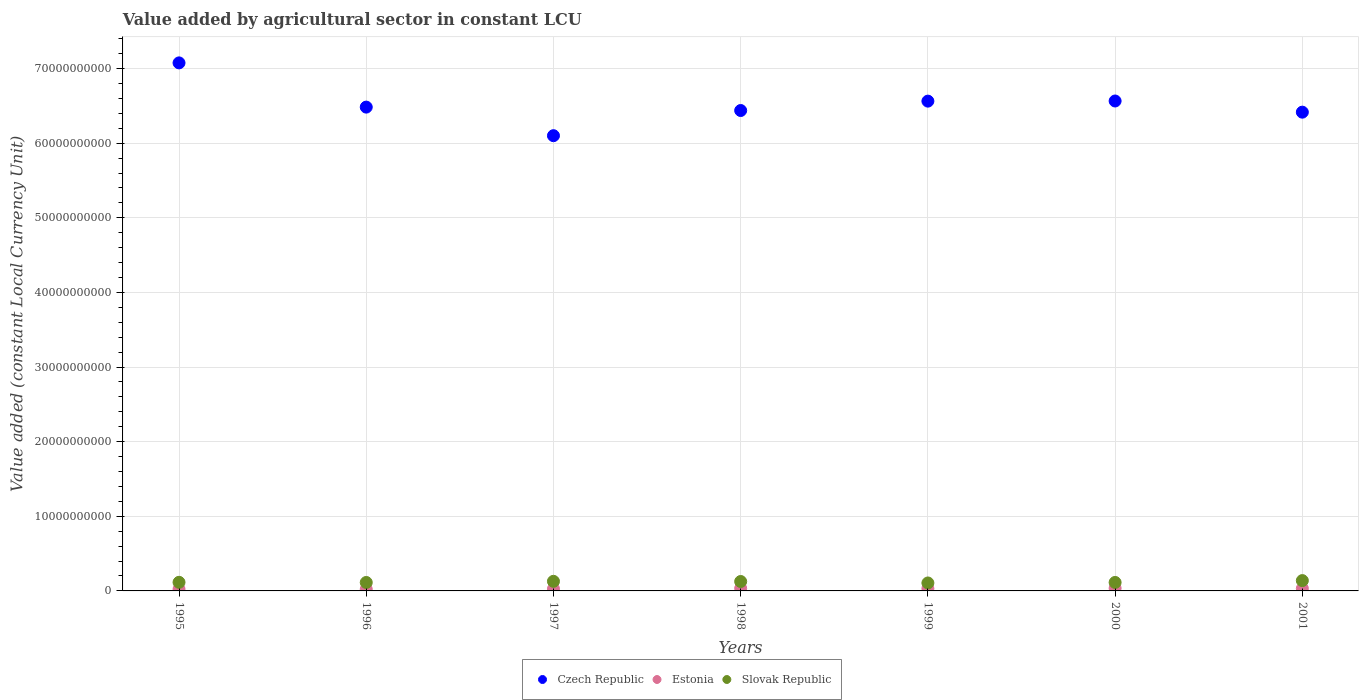What is the value added by agricultural sector in Estonia in 1998?
Offer a terse response. 3.44e+08. Across all years, what is the maximum value added by agricultural sector in Estonia?
Provide a short and direct response. 3.61e+08. Across all years, what is the minimum value added by agricultural sector in Estonia?
Offer a very short reply. 2.31e+08. In which year was the value added by agricultural sector in Estonia minimum?
Provide a short and direct response. 1995. What is the total value added by agricultural sector in Czech Republic in the graph?
Your answer should be very brief. 4.56e+11. What is the difference between the value added by agricultural sector in Czech Republic in 1998 and that in 1999?
Your answer should be compact. -1.26e+09. What is the difference between the value added by agricultural sector in Estonia in 1995 and the value added by agricultural sector in Czech Republic in 2000?
Offer a terse response. -6.54e+1. What is the average value added by agricultural sector in Estonia per year?
Offer a terse response. 2.97e+08. In the year 2000, what is the difference between the value added by agricultural sector in Czech Republic and value added by agricultural sector in Estonia?
Offer a terse response. 6.53e+1. What is the ratio of the value added by agricultural sector in Czech Republic in 2000 to that in 2001?
Offer a terse response. 1.02. Is the difference between the value added by agricultural sector in Czech Republic in 1996 and 1998 greater than the difference between the value added by agricultural sector in Estonia in 1996 and 1998?
Offer a very short reply. Yes. What is the difference between the highest and the second highest value added by agricultural sector in Slovak Republic?
Ensure brevity in your answer.  9.64e+07. What is the difference between the highest and the lowest value added by agricultural sector in Czech Republic?
Keep it short and to the point. 9.76e+09. Is the sum of the value added by agricultural sector in Czech Republic in 1996 and 1997 greater than the maximum value added by agricultural sector in Estonia across all years?
Your answer should be very brief. Yes. Is it the case that in every year, the sum of the value added by agricultural sector in Estonia and value added by agricultural sector in Czech Republic  is greater than the value added by agricultural sector in Slovak Republic?
Your response must be concise. Yes. Is the value added by agricultural sector in Slovak Republic strictly greater than the value added by agricultural sector in Estonia over the years?
Make the answer very short. Yes. Is the value added by agricultural sector in Estonia strictly less than the value added by agricultural sector in Slovak Republic over the years?
Offer a very short reply. Yes. How many years are there in the graph?
Ensure brevity in your answer.  7. What is the difference between two consecutive major ticks on the Y-axis?
Offer a very short reply. 1.00e+1. Does the graph contain grids?
Provide a succinct answer. Yes. Where does the legend appear in the graph?
Your response must be concise. Bottom center. How many legend labels are there?
Your answer should be very brief. 3. How are the legend labels stacked?
Offer a very short reply. Horizontal. What is the title of the graph?
Offer a terse response. Value added by agricultural sector in constant LCU. Does "Bermuda" appear as one of the legend labels in the graph?
Your answer should be compact. No. What is the label or title of the X-axis?
Make the answer very short. Years. What is the label or title of the Y-axis?
Ensure brevity in your answer.  Value added (constant Local Currency Unit). What is the Value added (constant Local Currency Unit) of Czech Republic in 1995?
Provide a short and direct response. 7.08e+1. What is the Value added (constant Local Currency Unit) of Estonia in 1995?
Make the answer very short. 2.31e+08. What is the Value added (constant Local Currency Unit) in Slovak Republic in 1995?
Make the answer very short. 1.15e+09. What is the Value added (constant Local Currency Unit) of Czech Republic in 1996?
Give a very brief answer. 6.48e+1. What is the Value added (constant Local Currency Unit) in Estonia in 1996?
Provide a succinct answer. 2.34e+08. What is the Value added (constant Local Currency Unit) in Slovak Republic in 1996?
Give a very brief answer. 1.13e+09. What is the Value added (constant Local Currency Unit) of Czech Republic in 1997?
Your answer should be very brief. 6.10e+1. What is the Value added (constant Local Currency Unit) of Estonia in 1997?
Make the answer very short. 2.73e+08. What is the Value added (constant Local Currency Unit) of Slovak Republic in 1997?
Ensure brevity in your answer.  1.29e+09. What is the Value added (constant Local Currency Unit) of Czech Republic in 1998?
Provide a succinct answer. 6.44e+1. What is the Value added (constant Local Currency Unit) of Estonia in 1998?
Give a very brief answer. 3.44e+08. What is the Value added (constant Local Currency Unit) in Slovak Republic in 1998?
Your response must be concise. 1.26e+09. What is the Value added (constant Local Currency Unit) of Czech Republic in 1999?
Keep it short and to the point. 6.56e+1. What is the Value added (constant Local Currency Unit) in Estonia in 1999?
Offer a very short reply. 3.06e+08. What is the Value added (constant Local Currency Unit) of Slovak Republic in 1999?
Your answer should be very brief. 1.07e+09. What is the Value added (constant Local Currency Unit) of Czech Republic in 2000?
Offer a very short reply. 6.56e+1. What is the Value added (constant Local Currency Unit) of Estonia in 2000?
Your response must be concise. 3.61e+08. What is the Value added (constant Local Currency Unit) in Slovak Republic in 2000?
Provide a short and direct response. 1.14e+09. What is the Value added (constant Local Currency Unit) in Czech Republic in 2001?
Ensure brevity in your answer.  6.42e+1. What is the Value added (constant Local Currency Unit) of Estonia in 2001?
Your answer should be compact. 3.27e+08. What is the Value added (constant Local Currency Unit) of Slovak Republic in 2001?
Provide a short and direct response. 1.38e+09. Across all years, what is the maximum Value added (constant Local Currency Unit) in Czech Republic?
Offer a terse response. 7.08e+1. Across all years, what is the maximum Value added (constant Local Currency Unit) of Estonia?
Offer a terse response. 3.61e+08. Across all years, what is the maximum Value added (constant Local Currency Unit) of Slovak Republic?
Provide a succinct answer. 1.38e+09. Across all years, what is the minimum Value added (constant Local Currency Unit) in Czech Republic?
Ensure brevity in your answer.  6.10e+1. Across all years, what is the minimum Value added (constant Local Currency Unit) of Estonia?
Ensure brevity in your answer.  2.31e+08. Across all years, what is the minimum Value added (constant Local Currency Unit) of Slovak Republic?
Offer a terse response. 1.07e+09. What is the total Value added (constant Local Currency Unit) of Czech Republic in the graph?
Offer a terse response. 4.56e+11. What is the total Value added (constant Local Currency Unit) of Estonia in the graph?
Your response must be concise. 2.08e+09. What is the total Value added (constant Local Currency Unit) of Slovak Republic in the graph?
Ensure brevity in your answer.  8.42e+09. What is the difference between the Value added (constant Local Currency Unit) of Czech Republic in 1995 and that in 1996?
Give a very brief answer. 5.93e+09. What is the difference between the Value added (constant Local Currency Unit) of Estonia in 1995 and that in 1996?
Offer a very short reply. -2.24e+06. What is the difference between the Value added (constant Local Currency Unit) in Slovak Republic in 1995 and that in 1996?
Keep it short and to the point. 2.13e+07. What is the difference between the Value added (constant Local Currency Unit) of Czech Republic in 1995 and that in 1997?
Provide a short and direct response. 9.76e+09. What is the difference between the Value added (constant Local Currency Unit) in Estonia in 1995 and that in 1997?
Give a very brief answer. -4.14e+07. What is the difference between the Value added (constant Local Currency Unit) of Slovak Republic in 1995 and that in 1997?
Offer a very short reply. -1.33e+08. What is the difference between the Value added (constant Local Currency Unit) of Czech Republic in 1995 and that in 1998?
Make the answer very short. 6.38e+09. What is the difference between the Value added (constant Local Currency Unit) of Estonia in 1995 and that in 1998?
Keep it short and to the point. -1.13e+08. What is the difference between the Value added (constant Local Currency Unit) in Slovak Republic in 1995 and that in 1998?
Provide a short and direct response. -1.09e+08. What is the difference between the Value added (constant Local Currency Unit) in Czech Republic in 1995 and that in 1999?
Your answer should be very brief. 5.12e+09. What is the difference between the Value added (constant Local Currency Unit) of Estonia in 1995 and that in 1999?
Your answer should be very brief. -7.44e+07. What is the difference between the Value added (constant Local Currency Unit) in Slovak Republic in 1995 and that in 1999?
Provide a short and direct response. 8.76e+07. What is the difference between the Value added (constant Local Currency Unit) in Czech Republic in 1995 and that in 2000?
Offer a very short reply. 5.11e+09. What is the difference between the Value added (constant Local Currency Unit) in Estonia in 1995 and that in 2000?
Your answer should be very brief. -1.29e+08. What is the difference between the Value added (constant Local Currency Unit) in Slovak Republic in 1995 and that in 2000?
Make the answer very short. 1.67e+07. What is the difference between the Value added (constant Local Currency Unit) of Czech Republic in 1995 and that in 2001?
Make the answer very short. 6.60e+09. What is the difference between the Value added (constant Local Currency Unit) of Estonia in 1995 and that in 2001?
Your response must be concise. -9.61e+07. What is the difference between the Value added (constant Local Currency Unit) in Slovak Republic in 1995 and that in 2001?
Provide a succinct answer. -2.29e+08. What is the difference between the Value added (constant Local Currency Unit) of Czech Republic in 1996 and that in 1997?
Give a very brief answer. 3.83e+09. What is the difference between the Value added (constant Local Currency Unit) of Estonia in 1996 and that in 1997?
Provide a succinct answer. -3.92e+07. What is the difference between the Value added (constant Local Currency Unit) in Slovak Republic in 1996 and that in 1997?
Keep it short and to the point. -1.54e+08. What is the difference between the Value added (constant Local Currency Unit) in Czech Republic in 1996 and that in 1998?
Your answer should be compact. 4.56e+08. What is the difference between the Value added (constant Local Currency Unit) in Estonia in 1996 and that in 1998?
Your response must be concise. -1.10e+08. What is the difference between the Value added (constant Local Currency Unit) of Slovak Republic in 1996 and that in 1998?
Provide a short and direct response. -1.30e+08. What is the difference between the Value added (constant Local Currency Unit) in Czech Republic in 1996 and that in 1999?
Your response must be concise. -8.02e+08. What is the difference between the Value added (constant Local Currency Unit) of Estonia in 1996 and that in 1999?
Make the answer very short. -7.21e+07. What is the difference between the Value added (constant Local Currency Unit) of Slovak Republic in 1996 and that in 1999?
Offer a very short reply. 6.63e+07. What is the difference between the Value added (constant Local Currency Unit) of Czech Republic in 1996 and that in 2000?
Provide a succinct answer. -8.20e+08. What is the difference between the Value added (constant Local Currency Unit) of Estonia in 1996 and that in 2000?
Your answer should be very brief. -1.27e+08. What is the difference between the Value added (constant Local Currency Unit) of Slovak Republic in 1996 and that in 2000?
Your answer should be very brief. -4.54e+06. What is the difference between the Value added (constant Local Currency Unit) in Czech Republic in 1996 and that in 2001?
Make the answer very short. 6.77e+08. What is the difference between the Value added (constant Local Currency Unit) of Estonia in 1996 and that in 2001?
Ensure brevity in your answer.  -9.39e+07. What is the difference between the Value added (constant Local Currency Unit) in Slovak Republic in 1996 and that in 2001?
Your answer should be compact. -2.51e+08. What is the difference between the Value added (constant Local Currency Unit) in Czech Republic in 1997 and that in 1998?
Offer a terse response. -3.37e+09. What is the difference between the Value added (constant Local Currency Unit) in Estonia in 1997 and that in 1998?
Your answer should be compact. -7.12e+07. What is the difference between the Value added (constant Local Currency Unit) of Slovak Republic in 1997 and that in 1998?
Offer a very short reply. 2.40e+07. What is the difference between the Value added (constant Local Currency Unit) of Czech Republic in 1997 and that in 1999?
Your response must be concise. -4.63e+09. What is the difference between the Value added (constant Local Currency Unit) of Estonia in 1997 and that in 1999?
Give a very brief answer. -3.29e+07. What is the difference between the Value added (constant Local Currency Unit) in Slovak Republic in 1997 and that in 1999?
Make the answer very short. 2.20e+08. What is the difference between the Value added (constant Local Currency Unit) in Czech Republic in 1997 and that in 2000?
Keep it short and to the point. -4.65e+09. What is the difference between the Value added (constant Local Currency Unit) of Estonia in 1997 and that in 2000?
Offer a very short reply. -8.80e+07. What is the difference between the Value added (constant Local Currency Unit) in Slovak Republic in 1997 and that in 2000?
Provide a short and direct response. 1.50e+08. What is the difference between the Value added (constant Local Currency Unit) in Czech Republic in 1997 and that in 2001?
Your response must be concise. -3.15e+09. What is the difference between the Value added (constant Local Currency Unit) in Estonia in 1997 and that in 2001?
Your answer should be compact. -5.47e+07. What is the difference between the Value added (constant Local Currency Unit) in Slovak Republic in 1997 and that in 2001?
Offer a terse response. -9.64e+07. What is the difference between the Value added (constant Local Currency Unit) in Czech Republic in 1998 and that in 1999?
Ensure brevity in your answer.  -1.26e+09. What is the difference between the Value added (constant Local Currency Unit) in Estonia in 1998 and that in 1999?
Provide a succinct answer. 3.83e+07. What is the difference between the Value added (constant Local Currency Unit) of Slovak Republic in 1998 and that in 1999?
Keep it short and to the point. 1.96e+08. What is the difference between the Value added (constant Local Currency Unit) of Czech Republic in 1998 and that in 2000?
Give a very brief answer. -1.28e+09. What is the difference between the Value added (constant Local Currency Unit) of Estonia in 1998 and that in 2000?
Keep it short and to the point. -1.67e+07. What is the difference between the Value added (constant Local Currency Unit) of Slovak Republic in 1998 and that in 2000?
Provide a succinct answer. 1.26e+08. What is the difference between the Value added (constant Local Currency Unit) of Czech Republic in 1998 and that in 2001?
Offer a very short reply. 2.21e+08. What is the difference between the Value added (constant Local Currency Unit) of Estonia in 1998 and that in 2001?
Your response must be concise. 1.66e+07. What is the difference between the Value added (constant Local Currency Unit) in Slovak Republic in 1998 and that in 2001?
Make the answer very short. -1.20e+08. What is the difference between the Value added (constant Local Currency Unit) of Czech Republic in 1999 and that in 2000?
Your answer should be compact. -1.80e+07. What is the difference between the Value added (constant Local Currency Unit) in Estonia in 1999 and that in 2000?
Provide a succinct answer. -5.50e+07. What is the difference between the Value added (constant Local Currency Unit) of Slovak Republic in 1999 and that in 2000?
Make the answer very short. -7.09e+07. What is the difference between the Value added (constant Local Currency Unit) in Czech Republic in 1999 and that in 2001?
Offer a very short reply. 1.48e+09. What is the difference between the Value added (constant Local Currency Unit) of Estonia in 1999 and that in 2001?
Offer a very short reply. -2.18e+07. What is the difference between the Value added (constant Local Currency Unit) in Slovak Republic in 1999 and that in 2001?
Offer a very short reply. -3.17e+08. What is the difference between the Value added (constant Local Currency Unit) of Czech Republic in 2000 and that in 2001?
Ensure brevity in your answer.  1.50e+09. What is the difference between the Value added (constant Local Currency Unit) in Estonia in 2000 and that in 2001?
Give a very brief answer. 3.33e+07. What is the difference between the Value added (constant Local Currency Unit) of Slovak Republic in 2000 and that in 2001?
Keep it short and to the point. -2.46e+08. What is the difference between the Value added (constant Local Currency Unit) of Czech Republic in 1995 and the Value added (constant Local Currency Unit) of Estonia in 1996?
Provide a succinct answer. 7.05e+1. What is the difference between the Value added (constant Local Currency Unit) in Czech Republic in 1995 and the Value added (constant Local Currency Unit) in Slovak Republic in 1996?
Your response must be concise. 6.96e+1. What is the difference between the Value added (constant Local Currency Unit) in Estonia in 1995 and the Value added (constant Local Currency Unit) in Slovak Republic in 1996?
Offer a very short reply. -9.01e+08. What is the difference between the Value added (constant Local Currency Unit) of Czech Republic in 1995 and the Value added (constant Local Currency Unit) of Estonia in 1997?
Provide a succinct answer. 7.05e+1. What is the difference between the Value added (constant Local Currency Unit) in Czech Republic in 1995 and the Value added (constant Local Currency Unit) in Slovak Republic in 1997?
Your response must be concise. 6.95e+1. What is the difference between the Value added (constant Local Currency Unit) of Estonia in 1995 and the Value added (constant Local Currency Unit) of Slovak Republic in 1997?
Your answer should be very brief. -1.05e+09. What is the difference between the Value added (constant Local Currency Unit) in Czech Republic in 1995 and the Value added (constant Local Currency Unit) in Estonia in 1998?
Keep it short and to the point. 7.04e+1. What is the difference between the Value added (constant Local Currency Unit) of Czech Republic in 1995 and the Value added (constant Local Currency Unit) of Slovak Republic in 1998?
Your response must be concise. 6.95e+1. What is the difference between the Value added (constant Local Currency Unit) of Estonia in 1995 and the Value added (constant Local Currency Unit) of Slovak Republic in 1998?
Offer a terse response. -1.03e+09. What is the difference between the Value added (constant Local Currency Unit) in Czech Republic in 1995 and the Value added (constant Local Currency Unit) in Estonia in 1999?
Provide a short and direct response. 7.05e+1. What is the difference between the Value added (constant Local Currency Unit) of Czech Republic in 1995 and the Value added (constant Local Currency Unit) of Slovak Republic in 1999?
Provide a succinct answer. 6.97e+1. What is the difference between the Value added (constant Local Currency Unit) of Estonia in 1995 and the Value added (constant Local Currency Unit) of Slovak Republic in 1999?
Ensure brevity in your answer.  -8.34e+08. What is the difference between the Value added (constant Local Currency Unit) in Czech Republic in 1995 and the Value added (constant Local Currency Unit) in Estonia in 2000?
Keep it short and to the point. 7.04e+1. What is the difference between the Value added (constant Local Currency Unit) in Czech Republic in 1995 and the Value added (constant Local Currency Unit) in Slovak Republic in 2000?
Ensure brevity in your answer.  6.96e+1. What is the difference between the Value added (constant Local Currency Unit) in Estonia in 1995 and the Value added (constant Local Currency Unit) in Slovak Republic in 2000?
Your answer should be compact. -9.05e+08. What is the difference between the Value added (constant Local Currency Unit) in Czech Republic in 1995 and the Value added (constant Local Currency Unit) in Estonia in 2001?
Offer a very short reply. 7.04e+1. What is the difference between the Value added (constant Local Currency Unit) in Czech Republic in 1995 and the Value added (constant Local Currency Unit) in Slovak Republic in 2001?
Offer a terse response. 6.94e+1. What is the difference between the Value added (constant Local Currency Unit) in Estonia in 1995 and the Value added (constant Local Currency Unit) in Slovak Republic in 2001?
Your answer should be compact. -1.15e+09. What is the difference between the Value added (constant Local Currency Unit) of Czech Republic in 1996 and the Value added (constant Local Currency Unit) of Estonia in 1997?
Your answer should be very brief. 6.46e+1. What is the difference between the Value added (constant Local Currency Unit) in Czech Republic in 1996 and the Value added (constant Local Currency Unit) in Slovak Republic in 1997?
Give a very brief answer. 6.35e+1. What is the difference between the Value added (constant Local Currency Unit) of Estonia in 1996 and the Value added (constant Local Currency Unit) of Slovak Republic in 1997?
Your answer should be compact. -1.05e+09. What is the difference between the Value added (constant Local Currency Unit) in Czech Republic in 1996 and the Value added (constant Local Currency Unit) in Estonia in 1998?
Keep it short and to the point. 6.45e+1. What is the difference between the Value added (constant Local Currency Unit) in Czech Republic in 1996 and the Value added (constant Local Currency Unit) in Slovak Republic in 1998?
Offer a very short reply. 6.36e+1. What is the difference between the Value added (constant Local Currency Unit) in Estonia in 1996 and the Value added (constant Local Currency Unit) in Slovak Republic in 1998?
Make the answer very short. -1.03e+09. What is the difference between the Value added (constant Local Currency Unit) of Czech Republic in 1996 and the Value added (constant Local Currency Unit) of Estonia in 1999?
Your answer should be compact. 6.45e+1. What is the difference between the Value added (constant Local Currency Unit) of Czech Republic in 1996 and the Value added (constant Local Currency Unit) of Slovak Republic in 1999?
Provide a succinct answer. 6.38e+1. What is the difference between the Value added (constant Local Currency Unit) in Estonia in 1996 and the Value added (constant Local Currency Unit) in Slovak Republic in 1999?
Ensure brevity in your answer.  -8.32e+08. What is the difference between the Value added (constant Local Currency Unit) of Czech Republic in 1996 and the Value added (constant Local Currency Unit) of Estonia in 2000?
Your answer should be very brief. 6.45e+1. What is the difference between the Value added (constant Local Currency Unit) in Czech Republic in 1996 and the Value added (constant Local Currency Unit) in Slovak Republic in 2000?
Provide a short and direct response. 6.37e+1. What is the difference between the Value added (constant Local Currency Unit) in Estonia in 1996 and the Value added (constant Local Currency Unit) in Slovak Republic in 2000?
Keep it short and to the point. -9.03e+08. What is the difference between the Value added (constant Local Currency Unit) of Czech Republic in 1996 and the Value added (constant Local Currency Unit) of Estonia in 2001?
Your response must be concise. 6.45e+1. What is the difference between the Value added (constant Local Currency Unit) of Czech Republic in 1996 and the Value added (constant Local Currency Unit) of Slovak Republic in 2001?
Make the answer very short. 6.34e+1. What is the difference between the Value added (constant Local Currency Unit) of Estonia in 1996 and the Value added (constant Local Currency Unit) of Slovak Republic in 2001?
Make the answer very short. -1.15e+09. What is the difference between the Value added (constant Local Currency Unit) in Czech Republic in 1997 and the Value added (constant Local Currency Unit) in Estonia in 1998?
Offer a very short reply. 6.07e+1. What is the difference between the Value added (constant Local Currency Unit) in Czech Republic in 1997 and the Value added (constant Local Currency Unit) in Slovak Republic in 1998?
Provide a succinct answer. 5.97e+1. What is the difference between the Value added (constant Local Currency Unit) in Estonia in 1997 and the Value added (constant Local Currency Unit) in Slovak Republic in 1998?
Give a very brief answer. -9.90e+08. What is the difference between the Value added (constant Local Currency Unit) of Czech Republic in 1997 and the Value added (constant Local Currency Unit) of Estonia in 1999?
Ensure brevity in your answer.  6.07e+1. What is the difference between the Value added (constant Local Currency Unit) in Czech Republic in 1997 and the Value added (constant Local Currency Unit) in Slovak Republic in 1999?
Give a very brief answer. 5.99e+1. What is the difference between the Value added (constant Local Currency Unit) of Estonia in 1997 and the Value added (constant Local Currency Unit) of Slovak Republic in 1999?
Provide a succinct answer. -7.93e+08. What is the difference between the Value added (constant Local Currency Unit) of Czech Republic in 1997 and the Value added (constant Local Currency Unit) of Estonia in 2000?
Offer a very short reply. 6.06e+1. What is the difference between the Value added (constant Local Currency Unit) in Czech Republic in 1997 and the Value added (constant Local Currency Unit) in Slovak Republic in 2000?
Give a very brief answer. 5.99e+1. What is the difference between the Value added (constant Local Currency Unit) of Estonia in 1997 and the Value added (constant Local Currency Unit) of Slovak Republic in 2000?
Your response must be concise. -8.64e+08. What is the difference between the Value added (constant Local Currency Unit) in Czech Republic in 1997 and the Value added (constant Local Currency Unit) in Estonia in 2001?
Offer a very short reply. 6.07e+1. What is the difference between the Value added (constant Local Currency Unit) of Czech Republic in 1997 and the Value added (constant Local Currency Unit) of Slovak Republic in 2001?
Give a very brief answer. 5.96e+1. What is the difference between the Value added (constant Local Currency Unit) in Estonia in 1997 and the Value added (constant Local Currency Unit) in Slovak Republic in 2001?
Your answer should be very brief. -1.11e+09. What is the difference between the Value added (constant Local Currency Unit) in Czech Republic in 1998 and the Value added (constant Local Currency Unit) in Estonia in 1999?
Your response must be concise. 6.41e+1. What is the difference between the Value added (constant Local Currency Unit) of Czech Republic in 1998 and the Value added (constant Local Currency Unit) of Slovak Republic in 1999?
Ensure brevity in your answer.  6.33e+1. What is the difference between the Value added (constant Local Currency Unit) of Estonia in 1998 and the Value added (constant Local Currency Unit) of Slovak Republic in 1999?
Make the answer very short. -7.22e+08. What is the difference between the Value added (constant Local Currency Unit) of Czech Republic in 1998 and the Value added (constant Local Currency Unit) of Estonia in 2000?
Your answer should be compact. 6.40e+1. What is the difference between the Value added (constant Local Currency Unit) in Czech Republic in 1998 and the Value added (constant Local Currency Unit) in Slovak Republic in 2000?
Your answer should be compact. 6.32e+1. What is the difference between the Value added (constant Local Currency Unit) of Estonia in 1998 and the Value added (constant Local Currency Unit) of Slovak Republic in 2000?
Keep it short and to the point. -7.93e+08. What is the difference between the Value added (constant Local Currency Unit) of Czech Republic in 1998 and the Value added (constant Local Currency Unit) of Estonia in 2001?
Your response must be concise. 6.40e+1. What is the difference between the Value added (constant Local Currency Unit) of Czech Republic in 1998 and the Value added (constant Local Currency Unit) of Slovak Republic in 2001?
Give a very brief answer. 6.30e+1. What is the difference between the Value added (constant Local Currency Unit) in Estonia in 1998 and the Value added (constant Local Currency Unit) in Slovak Republic in 2001?
Your response must be concise. -1.04e+09. What is the difference between the Value added (constant Local Currency Unit) of Czech Republic in 1999 and the Value added (constant Local Currency Unit) of Estonia in 2000?
Keep it short and to the point. 6.53e+1. What is the difference between the Value added (constant Local Currency Unit) in Czech Republic in 1999 and the Value added (constant Local Currency Unit) in Slovak Republic in 2000?
Your answer should be very brief. 6.45e+1. What is the difference between the Value added (constant Local Currency Unit) of Estonia in 1999 and the Value added (constant Local Currency Unit) of Slovak Republic in 2000?
Give a very brief answer. -8.31e+08. What is the difference between the Value added (constant Local Currency Unit) of Czech Republic in 1999 and the Value added (constant Local Currency Unit) of Estonia in 2001?
Provide a short and direct response. 6.53e+1. What is the difference between the Value added (constant Local Currency Unit) in Czech Republic in 1999 and the Value added (constant Local Currency Unit) in Slovak Republic in 2001?
Your answer should be compact. 6.42e+1. What is the difference between the Value added (constant Local Currency Unit) in Estonia in 1999 and the Value added (constant Local Currency Unit) in Slovak Republic in 2001?
Your response must be concise. -1.08e+09. What is the difference between the Value added (constant Local Currency Unit) in Czech Republic in 2000 and the Value added (constant Local Currency Unit) in Estonia in 2001?
Keep it short and to the point. 6.53e+1. What is the difference between the Value added (constant Local Currency Unit) of Czech Republic in 2000 and the Value added (constant Local Currency Unit) of Slovak Republic in 2001?
Offer a very short reply. 6.43e+1. What is the difference between the Value added (constant Local Currency Unit) of Estonia in 2000 and the Value added (constant Local Currency Unit) of Slovak Republic in 2001?
Offer a terse response. -1.02e+09. What is the average Value added (constant Local Currency Unit) in Czech Republic per year?
Provide a succinct answer. 6.52e+1. What is the average Value added (constant Local Currency Unit) in Estonia per year?
Your response must be concise. 2.97e+08. What is the average Value added (constant Local Currency Unit) in Slovak Republic per year?
Your answer should be compact. 1.20e+09. In the year 1995, what is the difference between the Value added (constant Local Currency Unit) of Czech Republic and Value added (constant Local Currency Unit) of Estonia?
Offer a terse response. 7.05e+1. In the year 1995, what is the difference between the Value added (constant Local Currency Unit) of Czech Republic and Value added (constant Local Currency Unit) of Slovak Republic?
Provide a succinct answer. 6.96e+1. In the year 1995, what is the difference between the Value added (constant Local Currency Unit) in Estonia and Value added (constant Local Currency Unit) in Slovak Republic?
Make the answer very short. -9.22e+08. In the year 1996, what is the difference between the Value added (constant Local Currency Unit) of Czech Republic and Value added (constant Local Currency Unit) of Estonia?
Ensure brevity in your answer.  6.46e+1. In the year 1996, what is the difference between the Value added (constant Local Currency Unit) in Czech Republic and Value added (constant Local Currency Unit) in Slovak Republic?
Provide a short and direct response. 6.37e+1. In the year 1996, what is the difference between the Value added (constant Local Currency Unit) in Estonia and Value added (constant Local Currency Unit) in Slovak Republic?
Ensure brevity in your answer.  -8.99e+08. In the year 1997, what is the difference between the Value added (constant Local Currency Unit) in Czech Republic and Value added (constant Local Currency Unit) in Estonia?
Provide a short and direct response. 6.07e+1. In the year 1997, what is the difference between the Value added (constant Local Currency Unit) of Czech Republic and Value added (constant Local Currency Unit) of Slovak Republic?
Offer a terse response. 5.97e+1. In the year 1997, what is the difference between the Value added (constant Local Currency Unit) of Estonia and Value added (constant Local Currency Unit) of Slovak Republic?
Provide a succinct answer. -1.01e+09. In the year 1998, what is the difference between the Value added (constant Local Currency Unit) in Czech Republic and Value added (constant Local Currency Unit) in Estonia?
Keep it short and to the point. 6.40e+1. In the year 1998, what is the difference between the Value added (constant Local Currency Unit) in Czech Republic and Value added (constant Local Currency Unit) in Slovak Republic?
Your answer should be compact. 6.31e+1. In the year 1998, what is the difference between the Value added (constant Local Currency Unit) of Estonia and Value added (constant Local Currency Unit) of Slovak Republic?
Provide a succinct answer. -9.18e+08. In the year 1999, what is the difference between the Value added (constant Local Currency Unit) of Czech Republic and Value added (constant Local Currency Unit) of Estonia?
Your answer should be very brief. 6.53e+1. In the year 1999, what is the difference between the Value added (constant Local Currency Unit) of Czech Republic and Value added (constant Local Currency Unit) of Slovak Republic?
Keep it short and to the point. 6.46e+1. In the year 1999, what is the difference between the Value added (constant Local Currency Unit) of Estonia and Value added (constant Local Currency Unit) of Slovak Republic?
Your response must be concise. -7.60e+08. In the year 2000, what is the difference between the Value added (constant Local Currency Unit) of Czech Republic and Value added (constant Local Currency Unit) of Estonia?
Make the answer very short. 6.53e+1. In the year 2000, what is the difference between the Value added (constant Local Currency Unit) of Czech Republic and Value added (constant Local Currency Unit) of Slovak Republic?
Make the answer very short. 6.45e+1. In the year 2000, what is the difference between the Value added (constant Local Currency Unit) in Estonia and Value added (constant Local Currency Unit) in Slovak Republic?
Provide a short and direct response. -7.76e+08. In the year 2001, what is the difference between the Value added (constant Local Currency Unit) in Czech Republic and Value added (constant Local Currency Unit) in Estonia?
Offer a very short reply. 6.38e+1. In the year 2001, what is the difference between the Value added (constant Local Currency Unit) of Czech Republic and Value added (constant Local Currency Unit) of Slovak Republic?
Offer a terse response. 6.28e+1. In the year 2001, what is the difference between the Value added (constant Local Currency Unit) in Estonia and Value added (constant Local Currency Unit) in Slovak Republic?
Provide a short and direct response. -1.06e+09. What is the ratio of the Value added (constant Local Currency Unit) in Czech Republic in 1995 to that in 1996?
Your answer should be compact. 1.09. What is the ratio of the Value added (constant Local Currency Unit) of Estonia in 1995 to that in 1996?
Offer a very short reply. 0.99. What is the ratio of the Value added (constant Local Currency Unit) in Slovak Republic in 1995 to that in 1996?
Your answer should be very brief. 1.02. What is the ratio of the Value added (constant Local Currency Unit) in Czech Republic in 1995 to that in 1997?
Make the answer very short. 1.16. What is the ratio of the Value added (constant Local Currency Unit) in Estonia in 1995 to that in 1997?
Your answer should be compact. 0.85. What is the ratio of the Value added (constant Local Currency Unit) in Slovak Republic in 1995 to that in 1997?
Your answer should be compact. 0.9. What is the ratio of the Value added (constant Local Currency Unit) of Czech Republic in 1995 to that in 1998?
Give a very brief answer. 1.1. What is the ratio of the Value added (constant Local Currency Unit) in Estonia in 1995 to that in 1998?
Make the answer very short. 0.67. What is the ratio of the Value added (constant Local Currency Unit) of Slovak Republic in 1995 to that in 1998?
Your answer should be compact. 0.91. What is the ratio of the Value added (constant Local Currency Unit) in Czech Republic in 1995 to that in 1999?
Your answer should be compact. 1.08. What is the ratio of the Value added (constant Local Currency Unit) in Estonia in 1995 to that in 1999?
Provide a succinct answer. 0.76. What is the ratio of the Value added (constant Local Currency Unit) in Slovak Republic in 1995 to that in 1999?
Your answer should be very brief. 1.08. What is the ratio of the Value added (constant Local Currency Unit) of Czech Republic in 1995 to that in 2000?
Offer a very short reply. 1.08. What is the ratio of the Value added (constant Local Currency Unit) in Estonia in 1995 to that in 2000?
Offer a terse response. 0.64. What is the ratio of the Value added (constant Local Currency Unit) of Slovak Republic in 1995 to that in 2000?
Offer a terse response. 1.01. What is the ratio of the Value added (constant Local Currency Unit) in Czech Republic in 1995 to that in 2001?
Your response must be concise. 1.1. What is the ratio of the Value added (constant Local Currency Unit) of Estonia in 1995 to that in 2001?
Provide a short and direct response. 0.71. What is the ratio of the Value added (constant Local Currency Unit) in Slovak Republic in 1995 to that in 2001?
Your response must be concise. 0.83. What is the ratio of the Value added (constant Local Currency Unit) in Czech Republic in 1996 to that in 1997?
Your response must be concise. 1.06. What is the ratio of the Value added (constant Local Currency Unit) in Estonia in 1996 to that in 1997?
Offer a terse response. 0.86. What is the ratio of the Value added (constant Local Currency Unit) of Slovak Republic in 1996 to that in 1997?
Provide a short and direct response. 0.88. What is the ratio of the Value added (constant Local Currency Unit) in Czech Republic in 1996 to that in 1998?
Your response must be concise. 1.01. What is the ratio of the Value added (constant Local Currency Unit) of Estonia in 1996 to that in 1998?
Provide a short and direct response. 0.68. What is the ratio of the Value added (constant Local Currency Unit) of Slovak Republic in 1996 to that in 1998?
Offer a terse response. 0.9. What is the ratio of the Value added (constant Local Currency Unit) of Estonia in 1996 to that in 1999?
Keep it short and to the point. 0.76. What is the ratio of the Value added (constant Local Currency Unit) in Slovak Republic in 1996 to that in 1999?
Make the answer very short. 1.06. What is the ratio of the Value added (constant Local Currency Unit) in Czech Republic in 1996 to that in 2000?
Provide a succinct answer. 0.99. What is the ratio of the Value added (constant Local Currency Unit) of Estonia in 1996 to that in 2000?
Your answer should be very brief. 0.65. What is the ratio of the Value added (constant Local Currency Unit) of Slovak Republic in 1996 to that in 2000?
Your answer should be compact. 1. What is the ratio of the Value added (constant Local Currency Unit) of Czech Republic in 1996 to that in 2001?
Your answer should be compact. 1.01. What is the ratio of the Value added (constant Local Currency Unit) in Estonia in 1996 to that in 2001?
Provide a succinct answer. 0.71. What is the ratio of the Value added (constant Local Currency Unit) of Slovak Republic in 1996 to that in 2001?
Ensure brevity in your answer.  0.82. What is the ratio of the Value added (constant Local Currency Unit) of Czech Republic in 1997 to that in 1998?
Offer a terse response. 0.95. What is the ratio of the Value added (constant Local Currency Unit) in Estonia in 1997 to that in 1998?
Your answer should be very brief. 0.79. What is the ratio of the Value added (constant Local Currency Unit) in Czech Republic in 1997 to that in 1999?
Provide a short and direct response. 0.93. What is the ratio of the Value added (constant Local Currency Unit) in Estonia in 1997 to that in 1999?
Give a very brief answer. 0.89. What is the ratio of the Value added (constant Local Currency Unit) in Slovak Republic in 1997 to that in 1999?
Keep it short and to the point. 1.21. What is the ratio of the Value added (constant Local Currency Unit) of Czech Republic in 1997 to that in 2000?
Your response must be concise. 0.93. What is the ratio of the Value added (constant Local Currency Unit) in Estonia in 1997 to that in 2000?
Offer a very short reply. 0.76. What is the ratio of the Value added (constant Local Currency Unit) in Slovak Republic in 1997 to that in 2000?
Your answer should be compact. 1.13. What is the ratio of the Value added (constant Local Currency Unit) in Czech Republic in 1997 to that in 2001?
Give a very brief answer. 0.95. What is the ratio of the Value added (constant Local Currency Unit) in Estonia in 1997 to that in 2001?
Your answer should be very brief. 0.83. What is the ratio of the Value added (constant Local Currency Unit) in Slovak Republic in 1997 to that in 2001?
Your answer should be compact. 0.93. What is the ratio of the Value added (constant Local Currency Unit) of Czech Republic in 1998 to that in 1999?
Offer a terse response. 0.98. What is the ratio of the Value added (constant Local Currency Unit) of Estonia in 1998 to that in 1999?
Offer a terse response. 1.13. What is the ratio of the Value added (constant Local Currency Unit) in Slovak Republic in 1998 to that in 1999?
Your answer should be compact. 1.18. What is the ratio of the Value added (constant Local Currency Unit) in Czech Republic in 1998 to that in 2000?
Your response must be concise. 0.98. What is the ratio of the Value added (constant Local Currency Unit) in Estonia in 1998 to that in 2000?
Give a very brief answer. 0.95. What is the ratio of the Value added (constant Local Currency Unit) in Slovak Republic in 1998 to that in 2000?
Give a very brief answer. 1.11. What is the ratio of the Value added (constant Local Currency Unit) in Estonia in 1998 to that in 2001?
Provide a short and direct response. 1.05. What is the ratio of the Value added (constant Local Currency Unit) of Slovak Republic in 1998 to that in 2001?
Keep it short and to the point. 0.91. What is the ratio of the Value added (constant Local Currency Unit) of Czech Republic in 1999 to that in 2000?
Your response must be concise. 1. What is the ratio of the Value added (constant Local Currency Unit) in Estonia in 1999 to that in 2000?
Your answer should be compact. 0.85. What is the ratio of the Value added (constant Local Currency Unit) of Slovak Republic in 1999 to that in 2000?
Keep it short and to the point. 0.94. What is the ratio of the Value added (constant Local Currency Unit) in Czech Republic in 1999 to that in 2001?
Offer a very short reply. 1.02. What is the ratio of the Value added (constant Local Currency Unit) of Estonia in 1999 to that in 2001?
Provide a short and direct response. 0.93. What is the ratio of the Value added (constant Local Currency Unit) in Slovak Republic in 1999 to that in 2001?
Make the answer very short. 0.77. What is the ratio of the Value added (constant Local Currency Unit) of Czech Republic in 2000 to that in 2001?
Give a very brief answer. 1.02. What is the ratio of the Value added (constant Local Currency Unit) of Estonia in 2000 to that in 2001?
Ensure brevity in your answer.  1.1. What is the ratio of the Value added (constant Local Currency Unit) of Slovak Republic in 2000 to that in 2001?
Ensure brevity in your answer.  0.82. What is the difference between the highest and the second highest Value added (constant Local Currency Unit) in Czech Republic?
Ensure brevity in your answer.  5.11e+09. What is the difference between the highest and the second highest Value added (constant Local Currency Unit) of Estonia?
Provide a succinct answer. 1.67e+07. What is the difference between the highest and the second highest Value added (constant Local Currency Unit) in Slovak Republic?
Provide a succinct answer. 9.64e+07. What is the difference between the highest and the lowest Value added (constant Local Currency Unit) of Czech Republic?
Your response must be concise. 9.76e+09. What is the difference between the highest and the lowest Value added (constant Local Currency Unit) in Estonia?
Your response must be concise. 1.29e+08. What is the difference between the highest and the lowest Value added (constant Local Currency Unit) in Slovak Republic?
Give a very brief answer. 3.17e+08. 